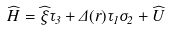Convert formula to latex. <formula><loc_0><loc_0><loc_500><loc_500>\widehat { H } = \widehat { \xi } \tau _ { 3 } + \Delta ( { r } ) \tau _ { 1 } \sigma _ { 2 } + \widehat { U }</formula> 